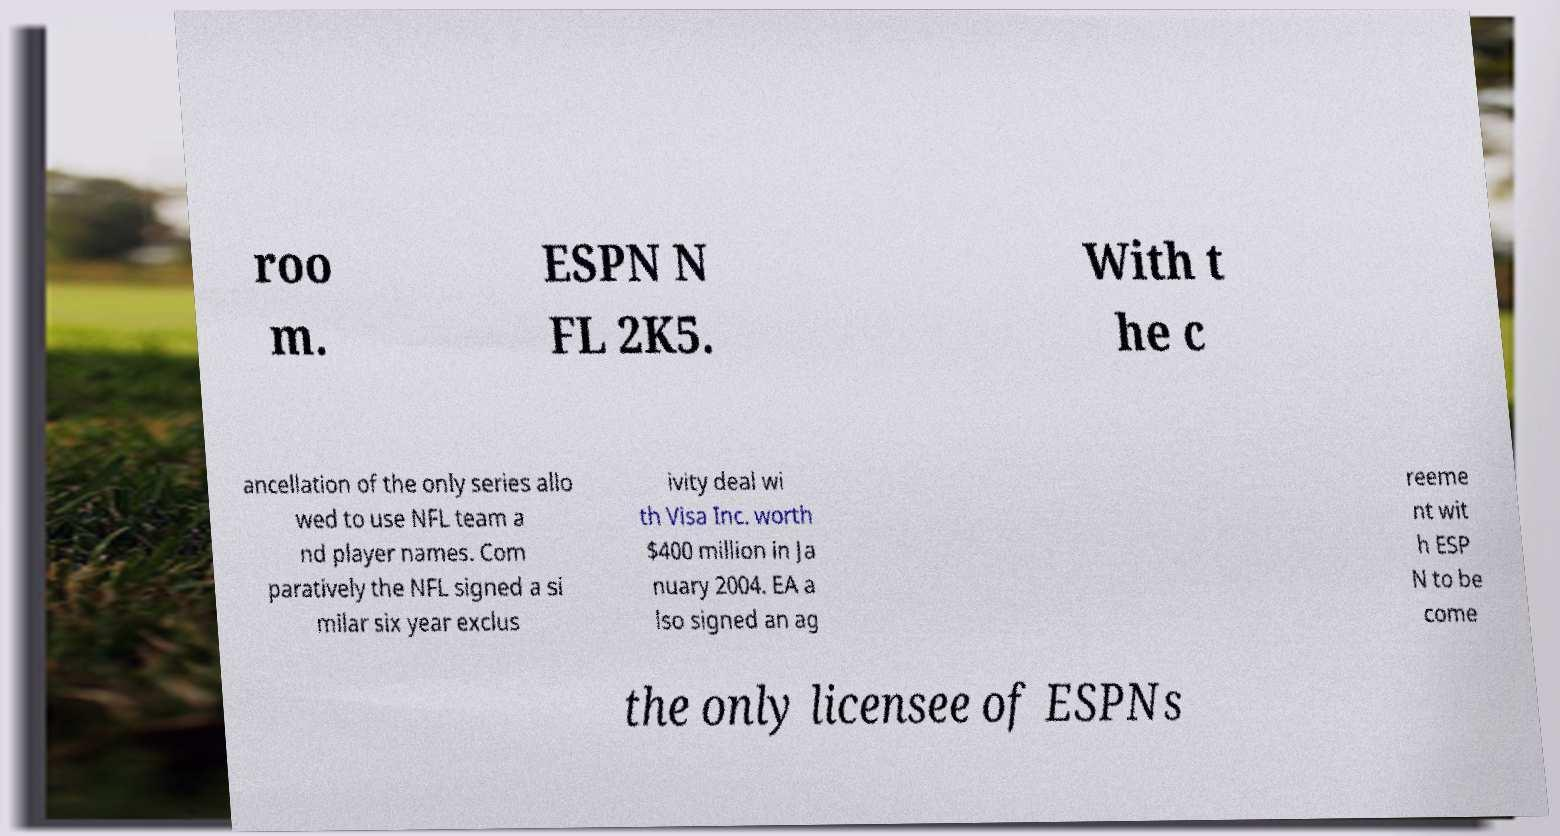I need the written content from this picture converted into text. Can you do that? roo m. ESPN N FL 2K5. With t he c ancellation of the only series allo wed to use NFL team a nd player names. Com paratively the NFL signed a si milar six year exclus ivity deal wi th Visa Inc. worth $400 million in Ja nuary 2004. EA a lso signed an ag reeme nt wit h ESP N to be come the only licensee of ESPNs 